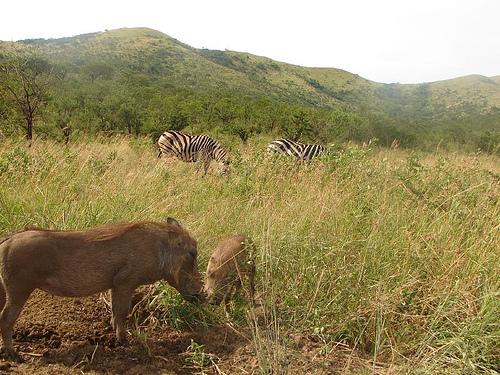With a focus on the animals, detail the subjects present in the image. The image showcases two zebras grazing in the grass, an adult brown boar pig, and a baby brown boar pig, all amidst tall green and yellow grass. Explain the main focus of the image and its surroundings. The main focus is two zebras and two brown boar pigs in a grassy area, with trees, green hills, and a clear sky in the background. Provide a description of the landscape and its elements in the image. The landscape features a grassy field populated by zebras and boars, surrounded by trees, green hills, and a clear blue sky. Describe the overall scene captured in the image. The image features a scenic view of a grassy field with zebras, boar pigs, green hills, and trees under a bright, cloudless sky. Give a concise description of the primary elements in the image. Two zebras are grazing in the grass, accompanied by a brown adult boar pig and a smaller brown boar pig, set against green hills and trees. Briefly describe the main activity taking place in the image. In the image, two zebras and two brown boar pigs are grazing in a grassy area, surrounded by a lush landscape and clear skies. Provide a brief summary of the main features in the image. The image shows two zebras grazing in grass, two brown boar pigs, clear skies, green hills, trees, and patches of brown dirt amidst tall grass. In a single sentence, convey the essence of the image. The image captures a serene moment in nature with zebras and boar pigs grazing in a grassy field surrounded by hills, trees, and a clear sky. Describe the notable colors and patterns found in the image. The image includes the black and white stripes of zebras, bright green grass and hills, brown boar pigs, brown tree trunks, and a clear gray sky. Present a succinct account of the primary subjects and environment in the image. Zebras and brown boar pigs are seen grazing in a grassy field, surrounded by trees, green hills, and a clear blue sky. 